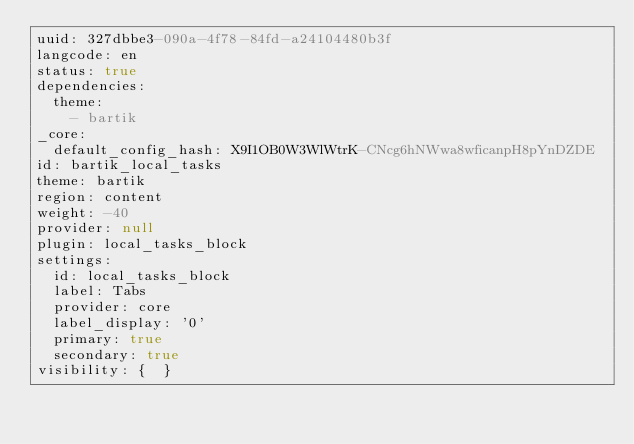<code> <loc_0><loc_0><loc_500><loc_500><_YAML_>uuid: 327dbbe3-090a-4f78-84fd-a24104480b3f
langcode: en
status: true
dependencies:
  theme:
    - bartik
_core:
  default_config_hash: X9I1OB0W3WlWtrK-CNcg6hNWwa8wficanpH8pYnDZDE
id: bartik_local_tasks
theme: bartik
region: content
weight: -40
provider: null
plugin: local_tasks_block
settings:
  id: local_tasks_block
  label: Tabs
  provider: core
  label_display: '0'
  primary: true
  secondary: true
visibility: {  }
</code> 